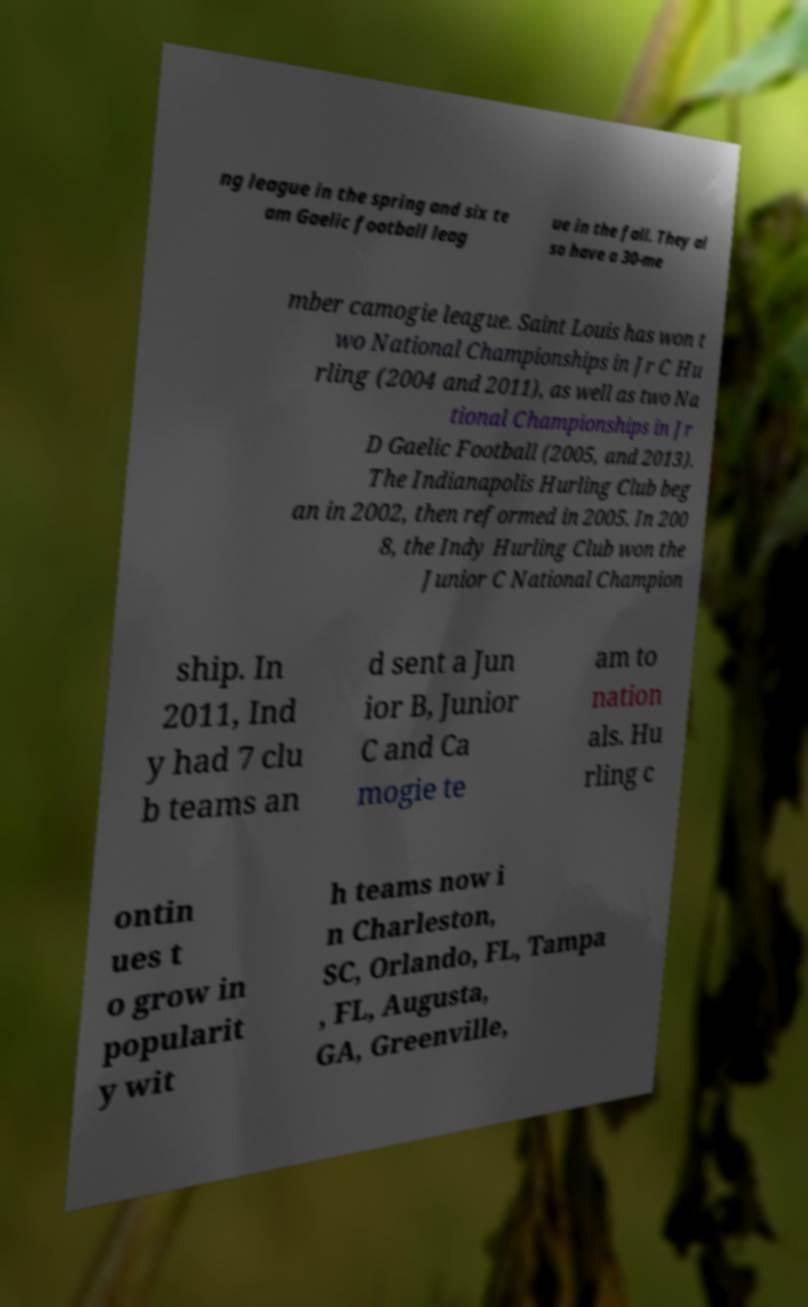I need the written content from this picture converted into text. Can you do that? ng league in the spring and six te am Gaelic football leag ue in the fall. They al so have a 30-me mber camogie league. Saint Louis has won t wo National Championships in Jr C Hu rling (2004 and 2011), as well as two Na tional Championships in Jr D Gaelic Football (2005, and 2013). The Indianapolis Hurling Club beg an in 2002, then reformed in 2005. In 200 8, the Indy Hurling Club won the Junior C National Champion ship. In 2011, Ind y had 7 clu b teams an d sent a Jun ior B, Junior C and Ca mogie te am to nation als. Hu rling c ontin ues t o grow in popularit y wit h teams now i n Charleston, SC, Orlando, FL, Tampa , FL, Augusta, GA, Greenville, 